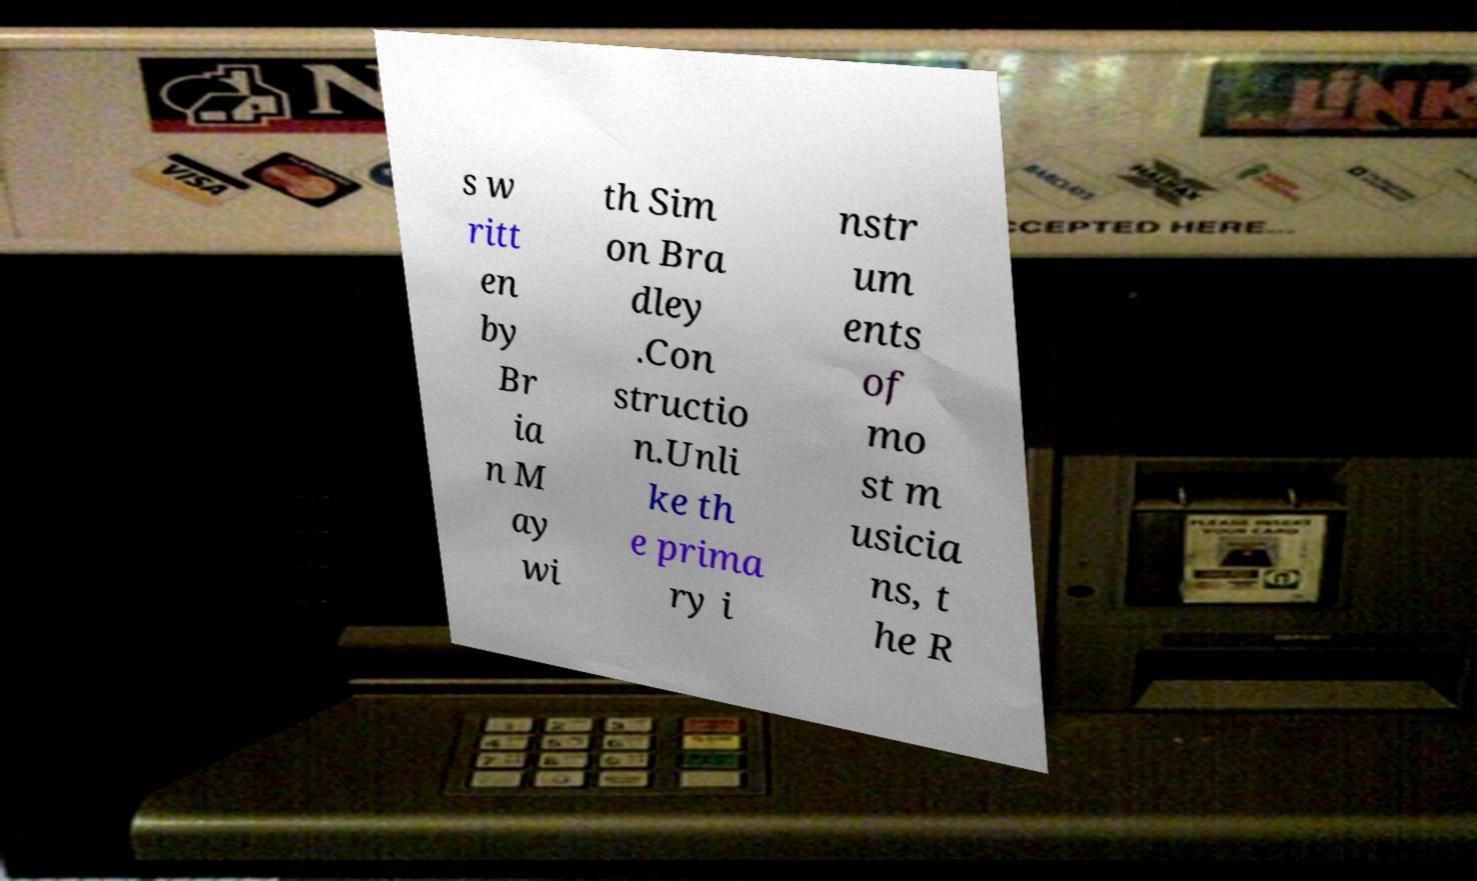For documentation purposes, I need the text within this image transcribed. Could you provide that? s w ritt en by Br ia n M ay wi th Sim on Bra dley .Con structio n.Unli ke th e prima ry i nstr um ents of mo st m usicia ns, t he R 